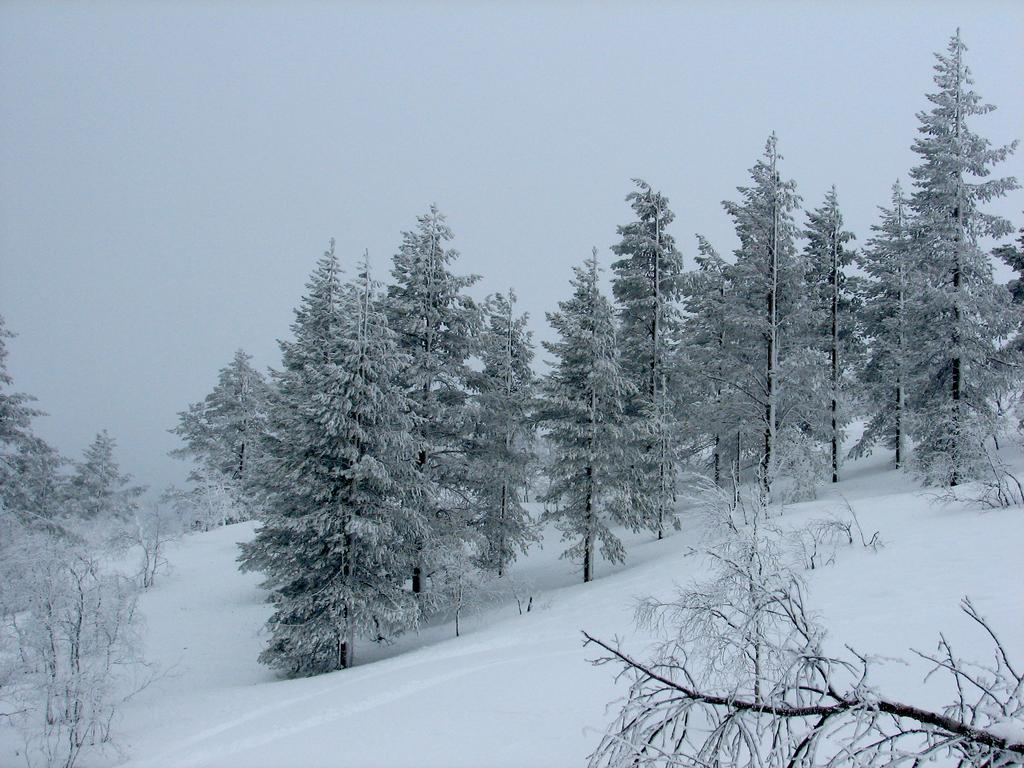What type of vegetation is visible in the image? There are trees in the image. What is covering the ground in the image? There is snow in the image. What part of the natural environment is visible in the image? The sky is visible in the background of the image. What type of coat is the tree wearing in the image? There is no coat present on the trees in the image. What part of the vehicle can be seen in the image? There is no vehicle present in the image. 